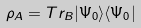<formula> <loc_0><loc_0><loc_500><loc_500>\rho _ { A } = T r _ { B } | \Psi _ { 0 } \rangle \langle \Psi _ { 0 } |</formula> 